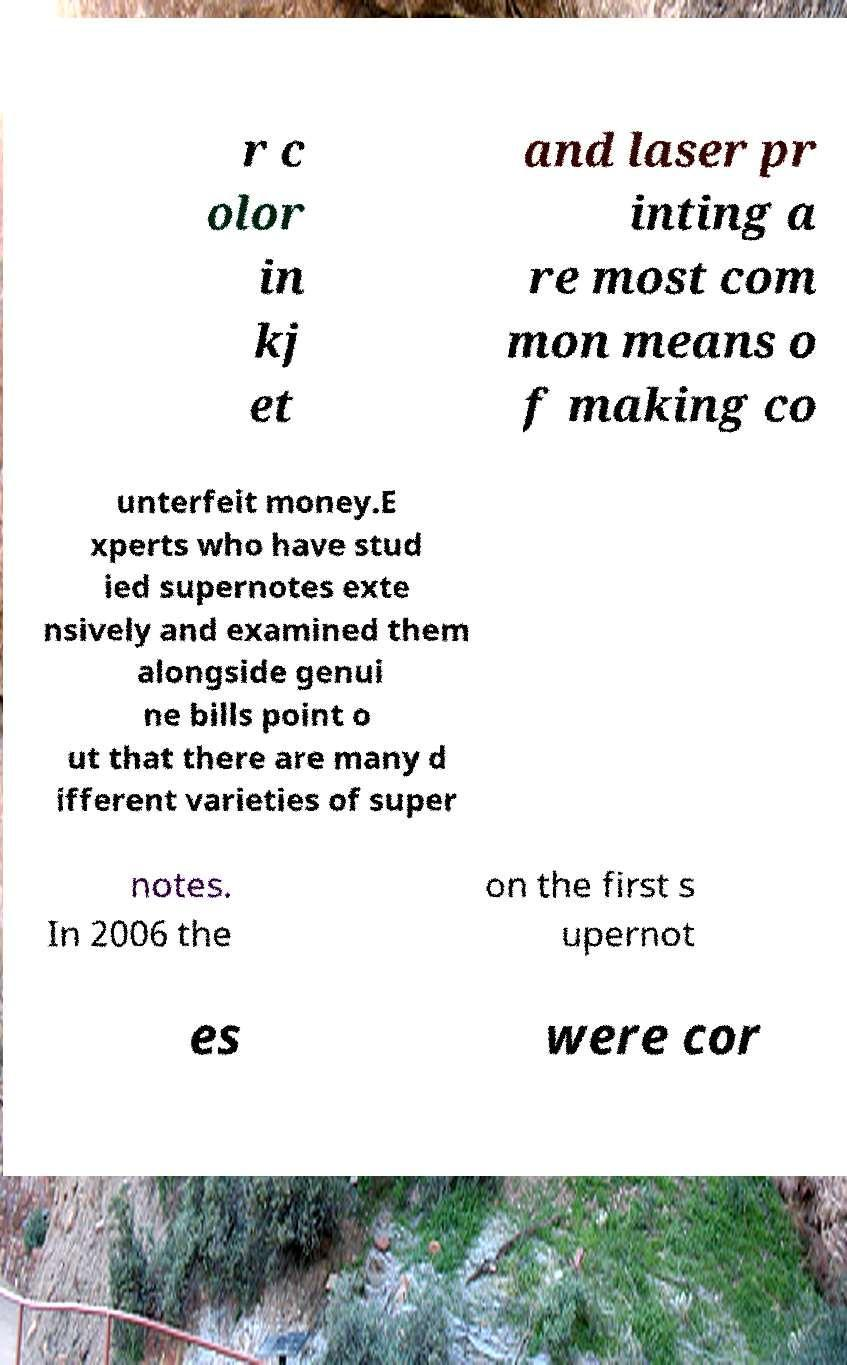What messages or text are displayed in this image? I need them in a readable, typed format. r c olor in kj et and laser pr inting a re most com mon means o f making co unterfeit money.E xperts who have stud ied supernotes exte nsively and examined them alongside genui ne bills point o ut that there are many d ifferent varieties of super notes. In 2006 the on the first s upernot es were cor 